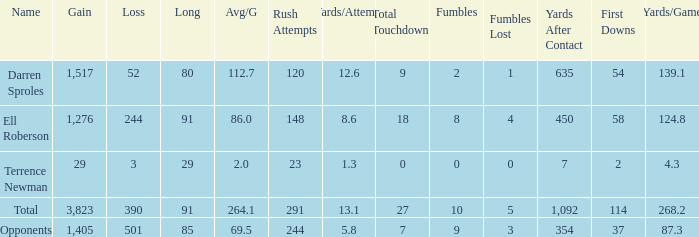When the gain is 29, and the average for each game is 2, and the player lost less than 390 yards, what's the sum of the long yards? None. 